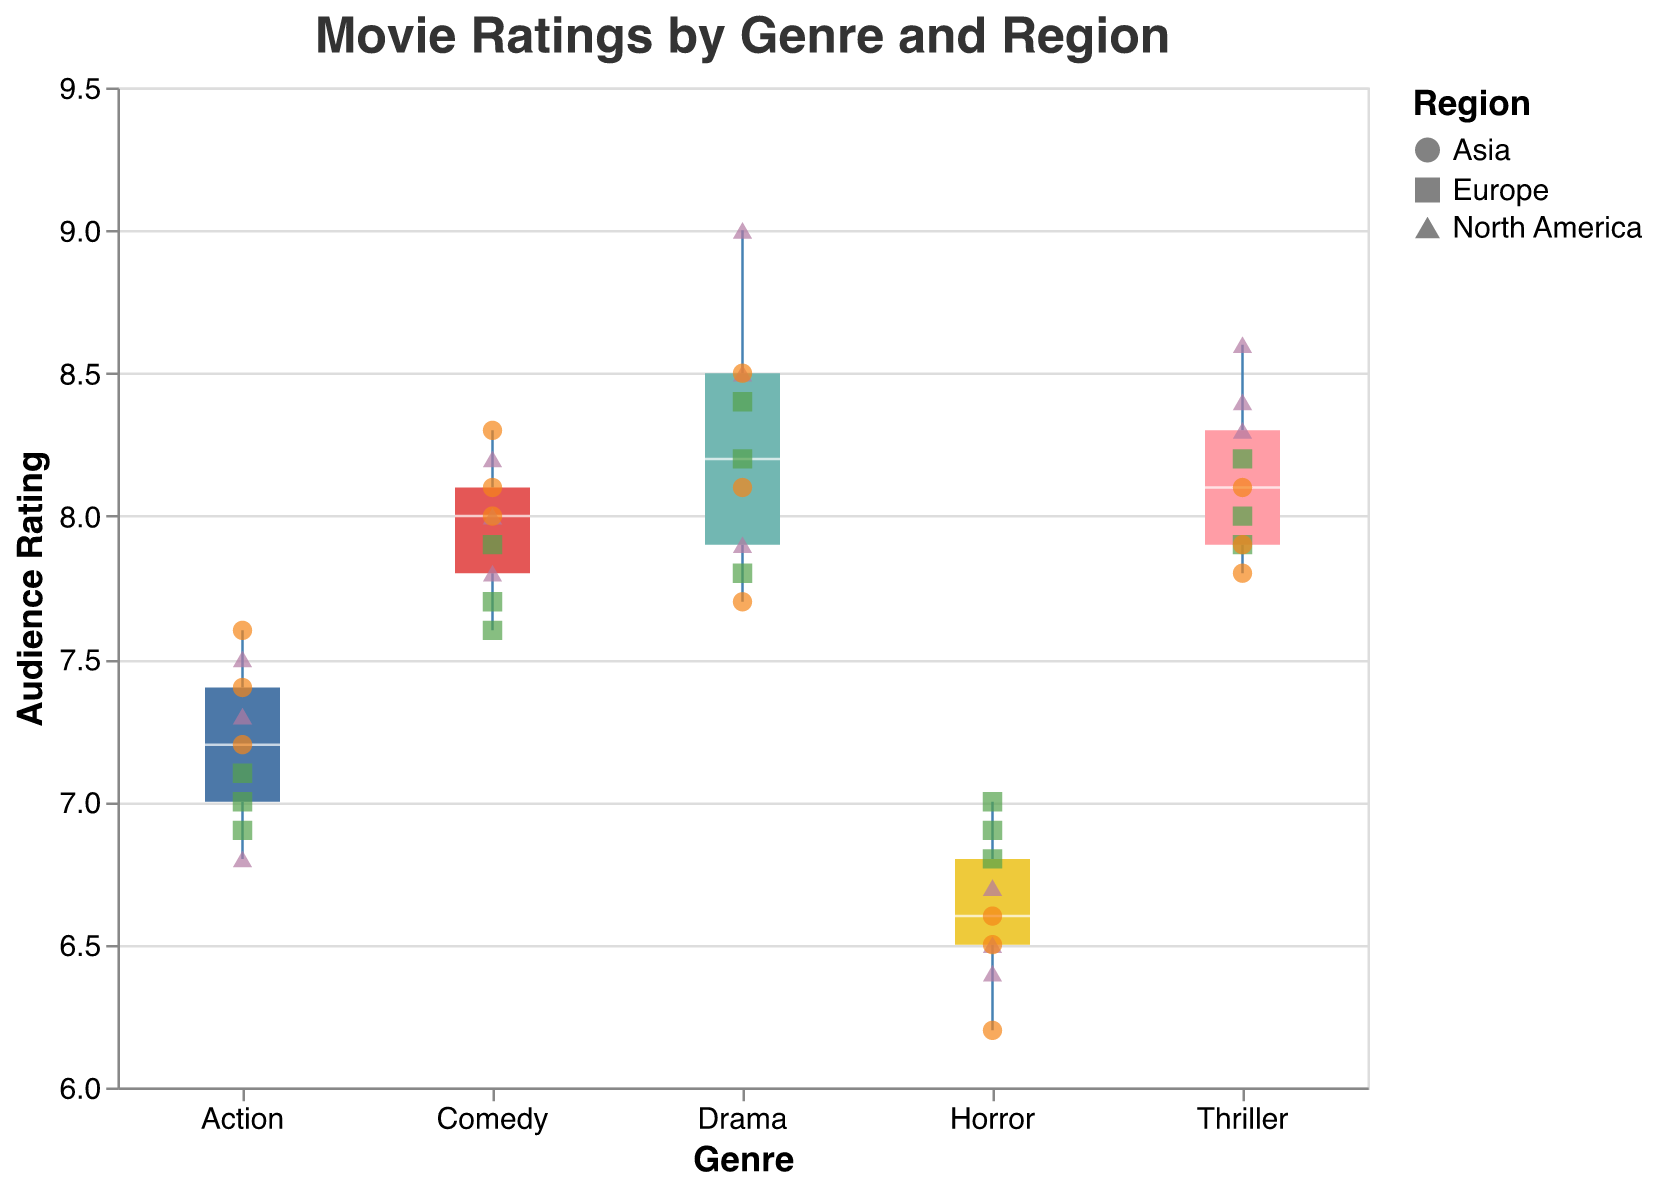What is the title of the figure? The title of the figure is displayed at the top of the chart in a larger font size. It reads "Movie Ratings by Genre and Region".
Answer: Movie Ratings by Genre and Region Which genre has the highest median rating? To determine the highest median rating, look at the horizontal line within the box of each genre's box plot. The highest line is in the Drama genre.
Answer: Drama How do the median ratings of Action movies compare across regions? Examine the position of data points within the box for Action movies. They are quite close across regions, indicating similar ratings with slight variation. North America has a slightly higher range of ratings than Europe and Asia.
Answer: Comparable, with North America slightly higher What are the range and interquartile range (IQR) of Thriller ratings? The range is found from the minimum to the maximum data points. For Thriller, the minimum is 7.8 and the maximum is 8.6, giving a range of 0.8. The IQR, from Q1 to Q3, ranges approximately from 8.0 to 8.3, giving an IQR of 0.3.
Answer: Range: 0.8, IQR: 0.3 In which region do Comedy movies receive the highest individual rating? By examining the individual scatter points for Comedy movies across regions, the highest rating is in Asia (8.3).
Answer: Asia Which genre has the widest spread of ratings in North America? Check the spread of individual data points for each genre within North America. Action movies exhibit a wider spread compared to other genres.
Answer: Action Are there any genres where the rating in Asia is consistently lower than in Europe? Review the scatter points comparing ratings in Asia and Europe for each genre. Horror movies in Asia have uniformly lower ratings than Europe.
Answer: Horror What is the median rating of Horror movies in Europe? Look at the horizontal line within the box of Horror movies for Europe, which represents the median. It is approximately 6.9.
Answer: 6.9 Which region shows the most variability in Action movie ratings? Variability is indicated by the spread of individual points. North America shows the most spread-out points for Action movies, indicating greater variability.
Answer: North America 